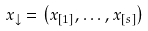Convert formula to latex. <formula><loc_0><loc_0><loc_500><loc_500>x _ { \downarrow } = \left ( x _ { [ 1 ] } , \dots , x _ { [ s ] } \right )</formula> 